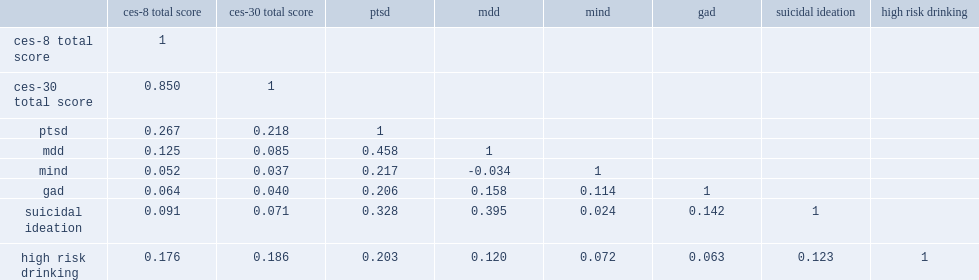What was the correlation of ces-8 and ces-30? 0.85. Which groups were correlated with highest total scores? 0.85. 